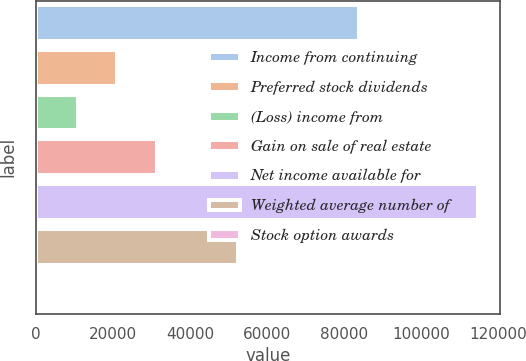Convert chart to OTSL. <chart><loc_0><loc_0><loc_500><loc_500><bar_chart><fcel>Income from continuing<fcel>Preferred stock dividends<fcel>(Loss) income from<fcel>Gain on sale of real estate<fcel>Net income available for<fcel>Weighted average number of<fcel>Stock option awards<nl><fcel>84009<fcel>21041<fcel>10779<fcel>31303<fcel>114795<fcel>52533<fcel>517<nl></chart> 